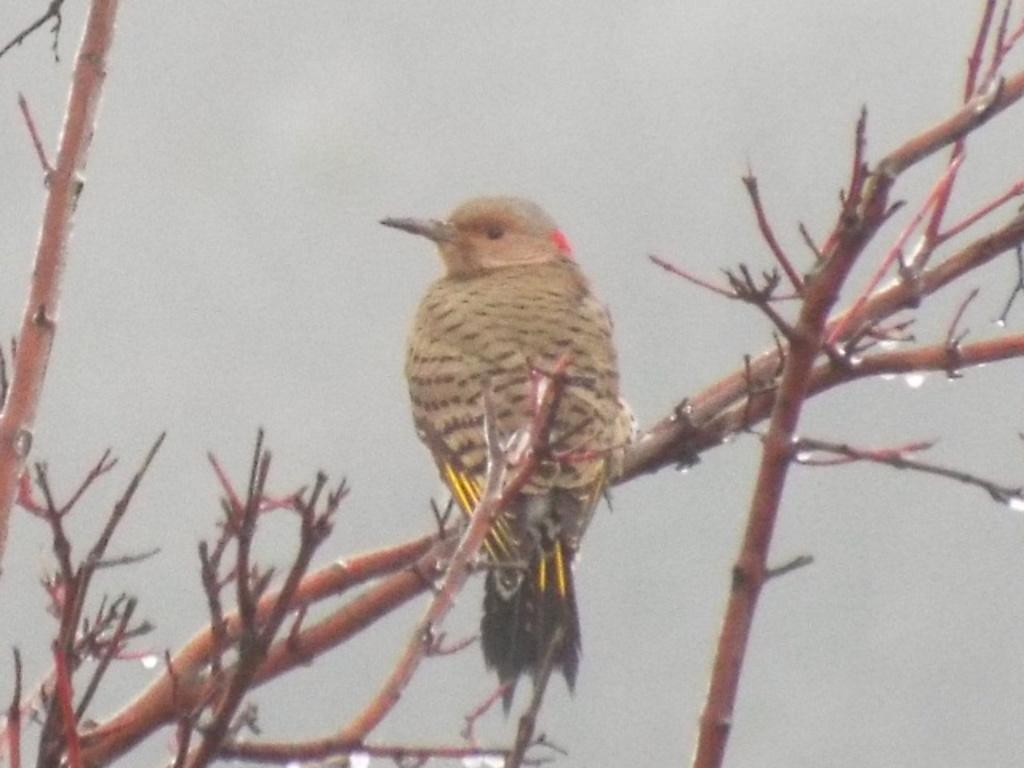What is the main subject of the image? There is a bird in the center of the image. Where is the bird located? The bird is on a stem. What else can be seen in the image besides the bird? There are branches in the image. What type of liquid can be seen dripping from the bird's beak in the image? There is no liquid dripping from the bird's beak in the image. Can you tell me the total cost of the items purchased, as shown on the receipt in the image? There is no receipt present in the image. 